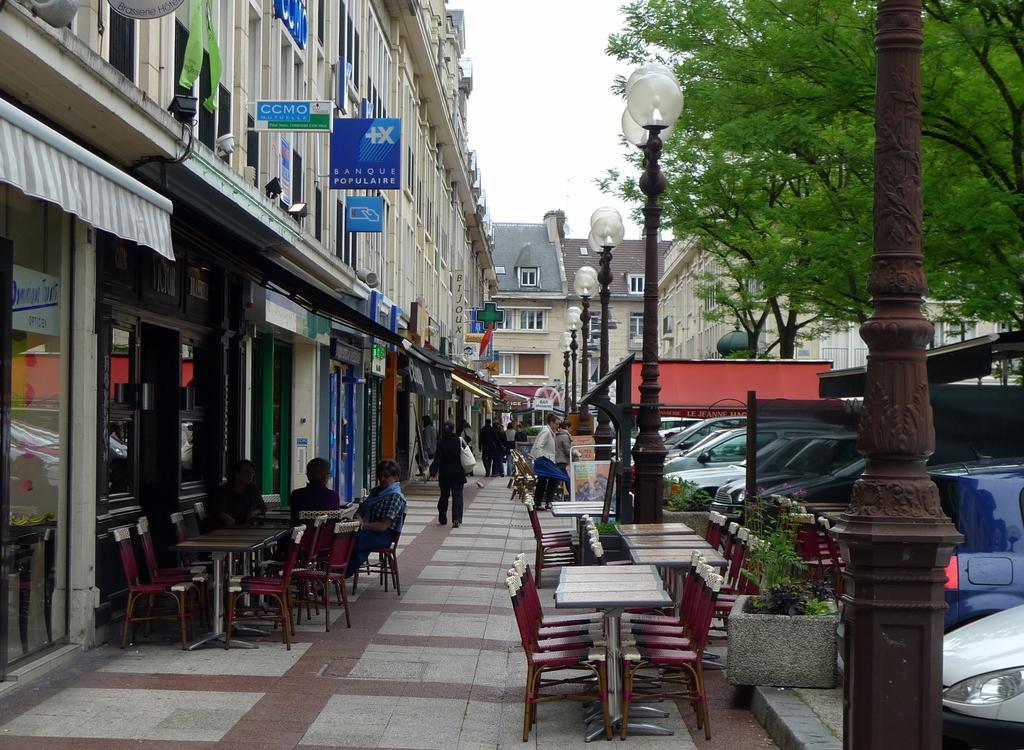Can you describe this image briefly? In the middle of the image few people are walking and few people are sitting on the chairs. Top right side of the image there are some trees. Bottom right side of the image there are some vehicles and plants. Top left side of the image there is a building. Bottom left side of the image there are some chairs and tables. 